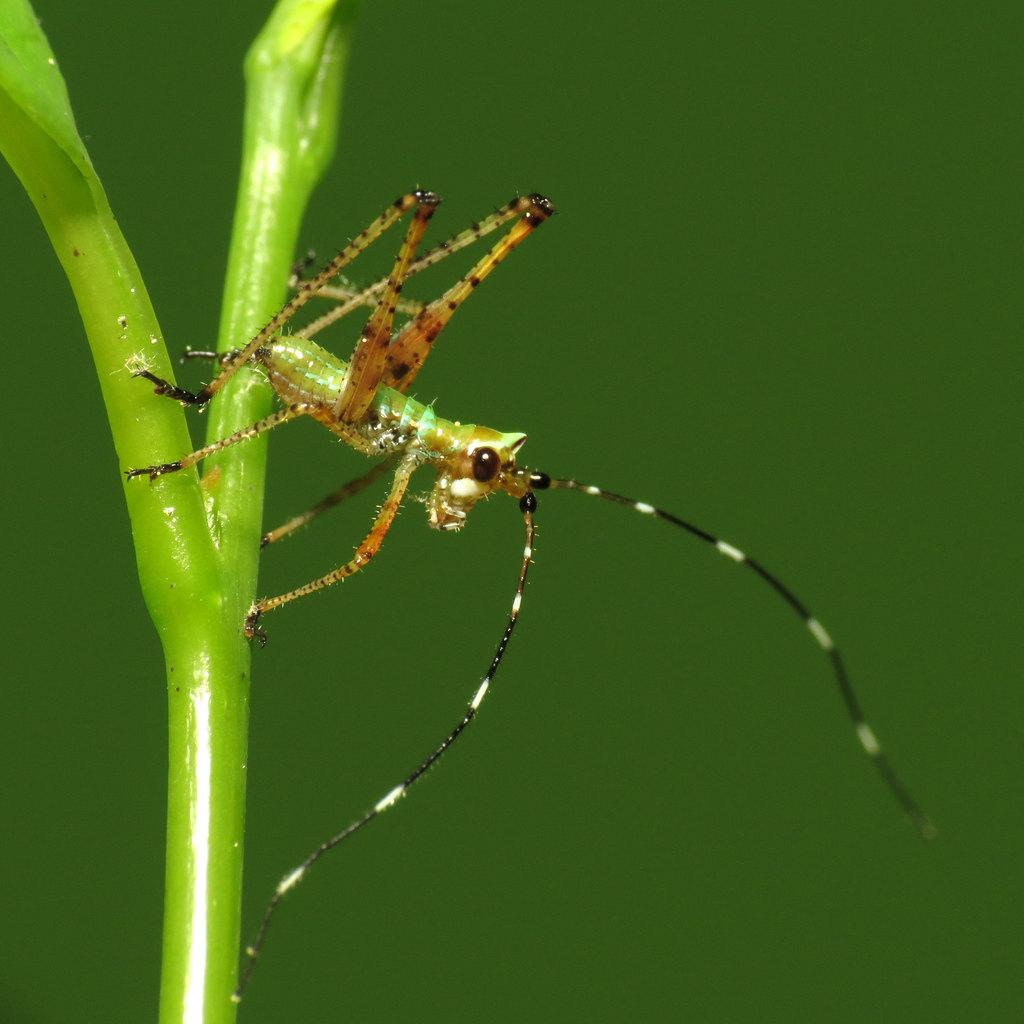What type of creature can be seen in the image? There is an insect in the image. What is the insect standing on? The insect is standing on a green object. What type of steam can be seen coming from the insect in the image? There is no steam present in the image; it features an insect standing on a green object. 